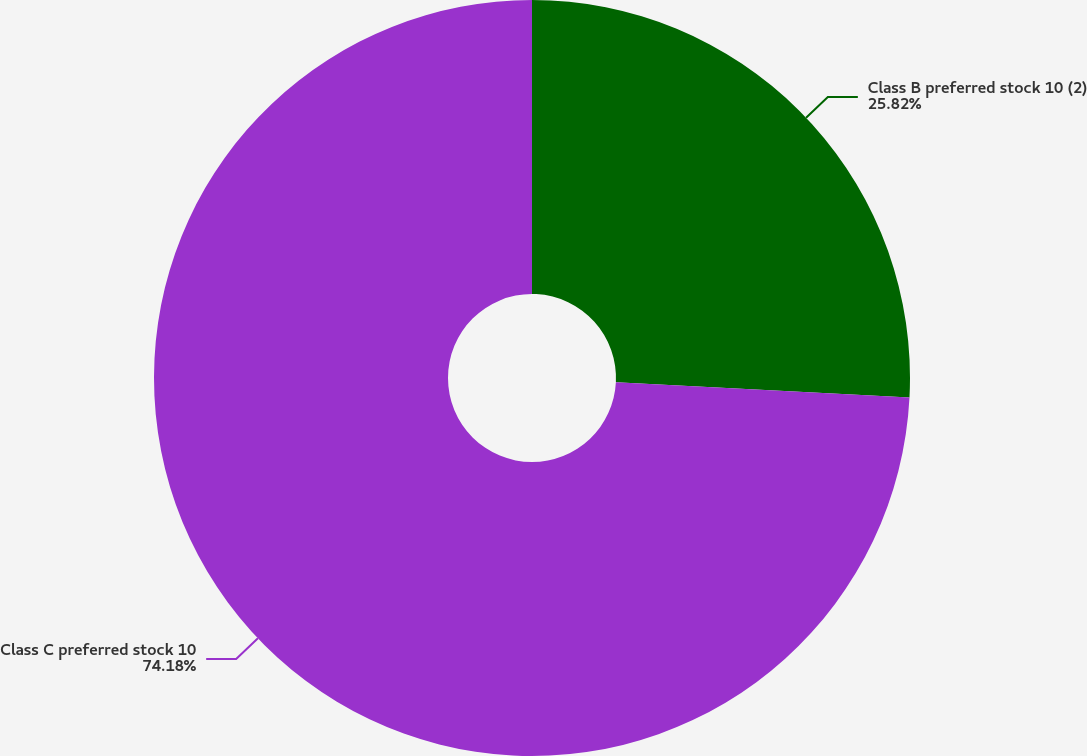<chart> <loc_0><loc_0><loc_500><loc_500><pie_chart><fcel>Class B preferred stock 10 (2)<fcel>Class C preferred stock 10<nl><fcel>25.82%<fcel>74.18%<nl></chart> 